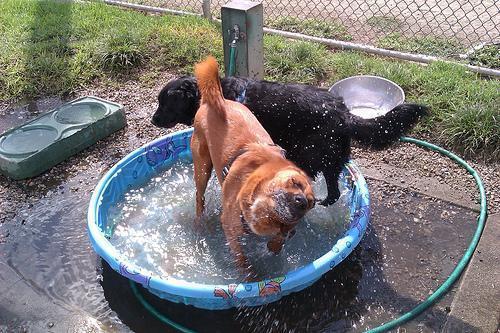How many dogs are there?
Give a very brief answer. 2. 